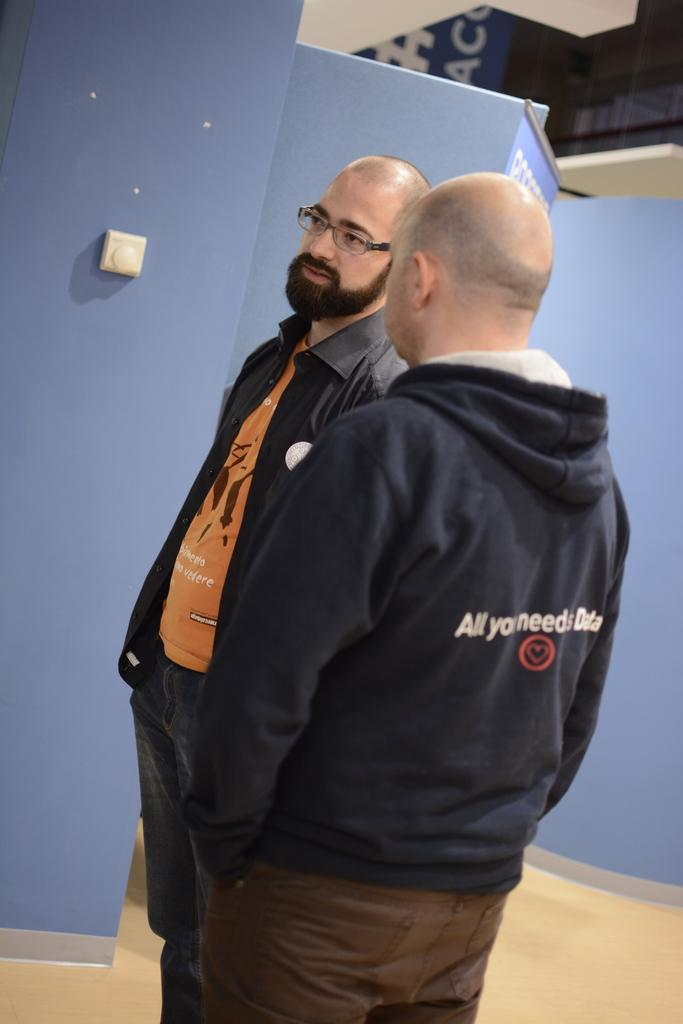How many people are in the image? There are two men standing in the image. What can be seen behind the men in the image? There is a wall in the image. What color is the wall? The wall is blue in color. What is the object hanging on the wall? The object is likely a banner. What is visible at the bottom of the image? The floor is visible at the bottom of the image. Can you describe the carpenter's tools used in the image? There is no carpenter or tools present in the image. How many times do the men jump in the image? There is no jumping or motion depicted in the image; the men are standing still. 